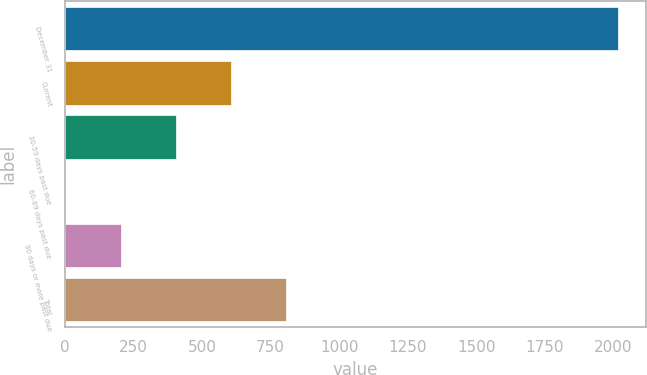Convert chart. <chart><loc_0><loc_0><loc_500><loc_500><bar_chart><fcel>December 31<fcel>Current<fcel>30-59 days past due<fcel>60-89 days past due<fcel>90 days or more past due<fcel>Total<nl><fcel>2017<fcel>605.73<fcel>404.12<fcel>0.9<fcel>202.51<fcel>807.34<nl></chart> 